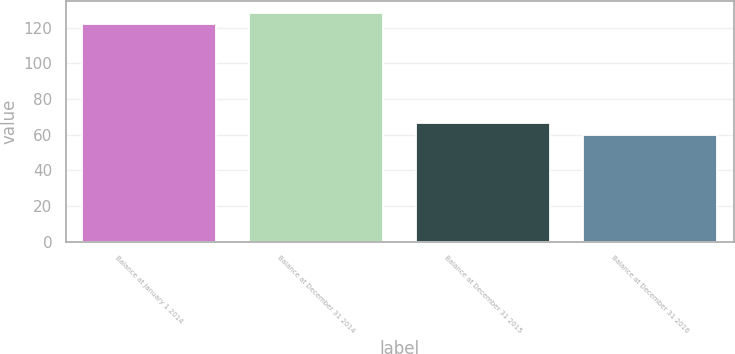Convert chart. <chart><loc_0><loc_0><loc_500><loc_500><bar_chart><fcel>Balance at January 1 2014<fcel>Balance at December 31 2014<fcel>Balance at December 31 2015<fcel>Balance at December 31 2016<nl><fcel>122<fcel>128.5<fcel>66.5<fcel>60<nl></chart> 